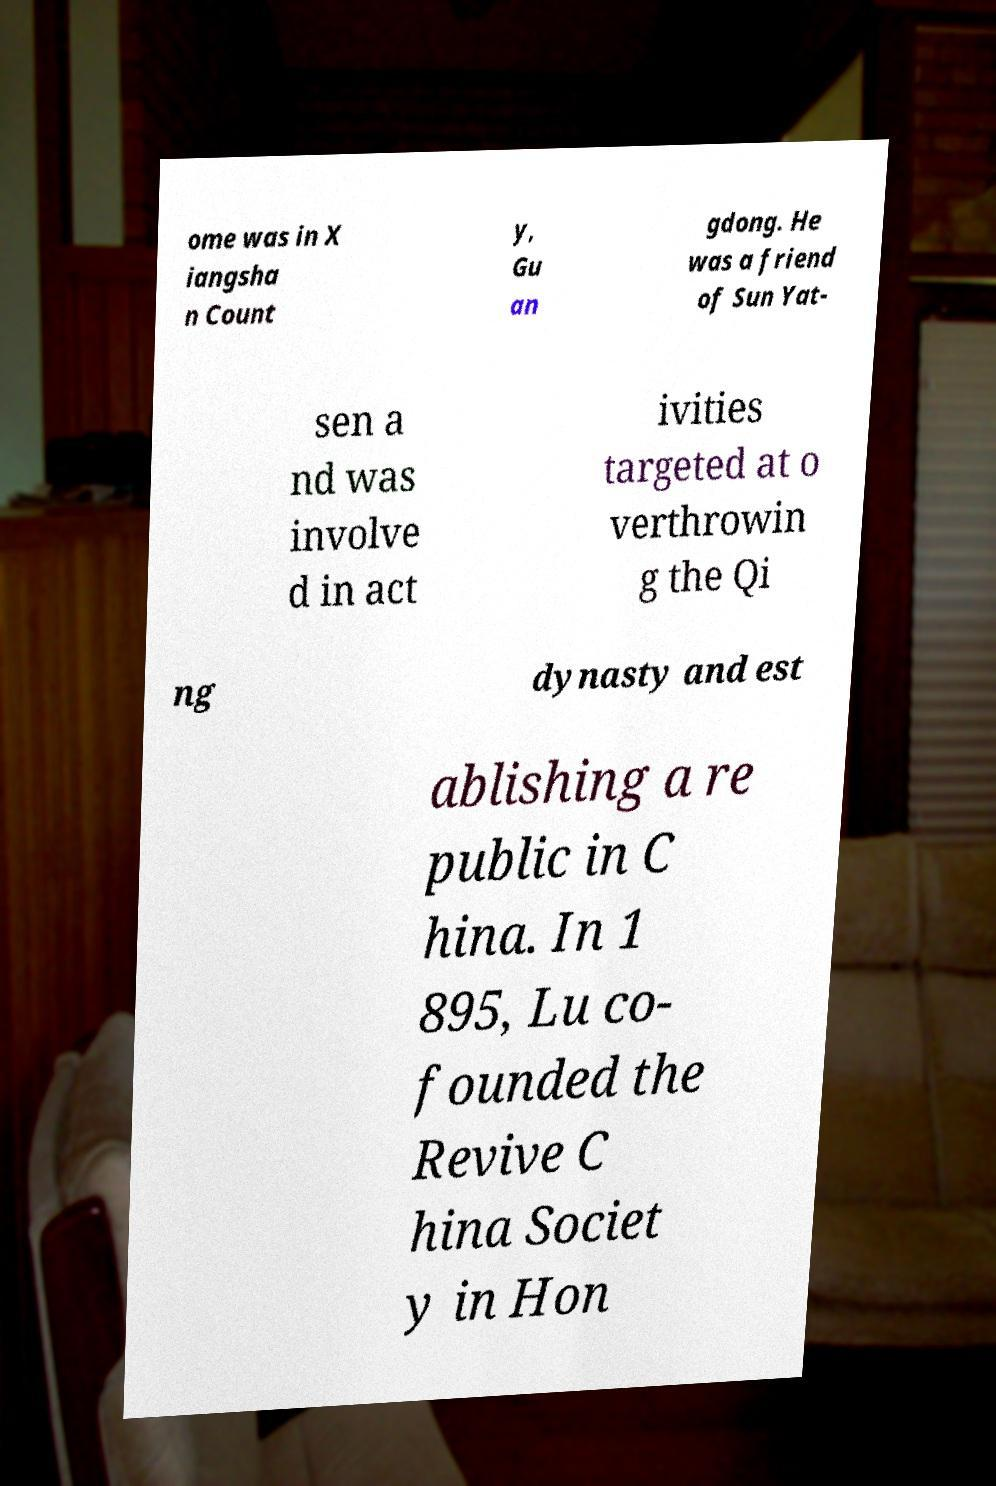I need the written content from this picture converted into text. Can you do that? ome was in X iangsha n Count y, Gu an gdong. He was a friend of Sun Yat- sen a nd was involve d in act ivities targeted at o verthrowin g the Qi ng dynasty and est ablishing a re public in C hina. In 1 895, Lu co- founded the Revive C hina Societ y in Hon 